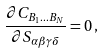Convert formula to latex. <formula><loc_0><loc_0><loc_500><loc_500>\frac { \partial C _ { B _ { 1 } \dots B _ { N } } } { \partial S _ { \alpha \beta \gamma \delta } } = 0 \, ,</formula> 